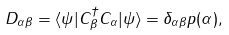Convert formula to latex. <formula><loc_0><loc_0><loc_500><loc_500>D _ { \alpha \beta } = \langle \psi | C _ { \beta } ^ { \dagger } C _ { \alpha } | \psi \rangle = \delta _ { \alpha \beta } p ( \alpha ) ,</formula> 